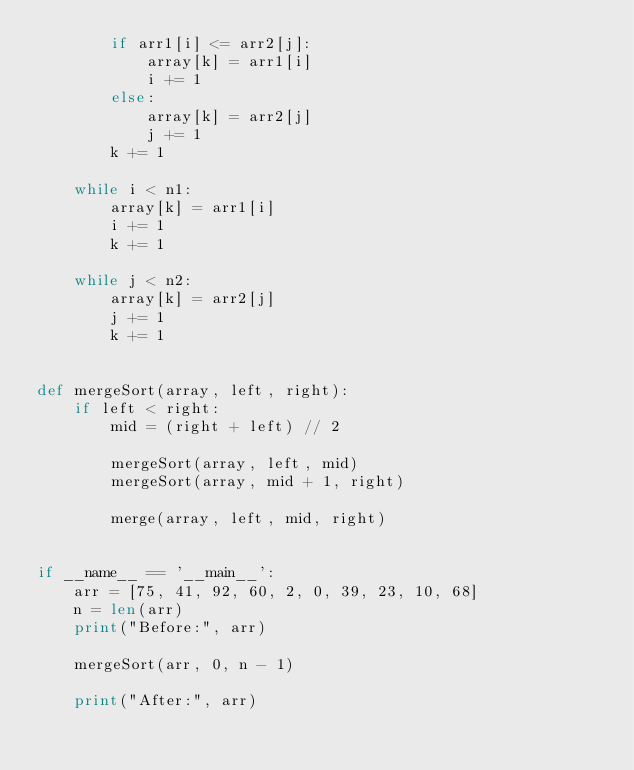<code> <loc_0><loc_0><loc_500><loc_500><_Python_>        if arr1[i] <= arr2[j]:
            array[k] = arr1[i]
            i += 1
        else:
            array[k] = arr2[j]
            j += 1
        k += 1

    while i < n1:
        array[k] = arr1[i]
        i += 1
        k += 1

    while j < n2:
        array[k] = arr2[j]
        j += 1
        k += 1


def mergeSort(array, left, right):
    if left < right:
        mid = (right + left) // 2

        mergeSort(array, left, mid)
        mergeSort(array, mid + 1, right)

        merge(array, left, mid, right)


if __name__ == '__main__':
    arr = [75, 41, 92, 60, 2, 0, 39, 23, 10, 68]
    n = len(arr)
    print("Before:", arr)

    mergeSort(arr, 0, n - 1)

    print("After:", arr)
</code> 